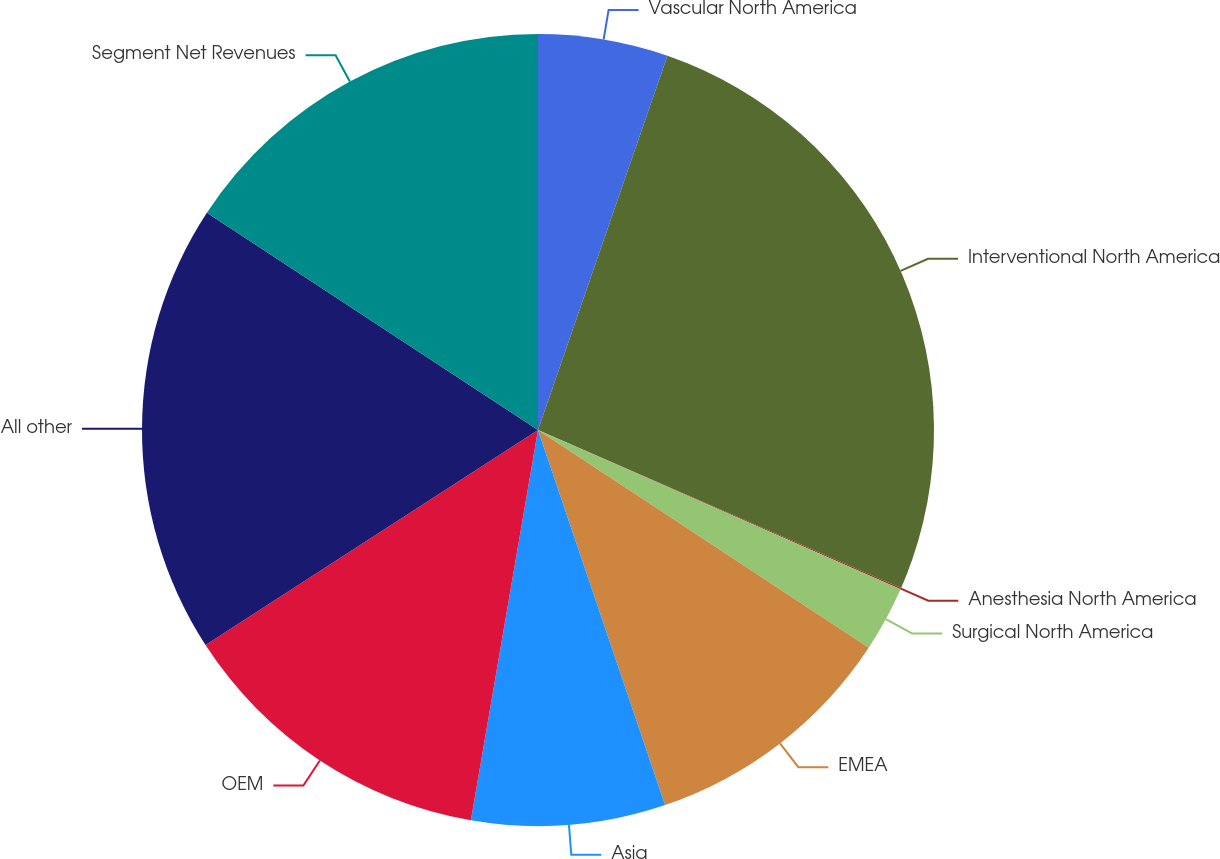<chart> <loc_0><loc_0><loc_500><loc_500><pie_chart><fcel>Vascular North America<fcel>Interventional North America<fcel>Anesthesia North America<fcel>Surgical North America<fcel>EMEA<fcel>Asia<fcel>OEM<fcel>All other<fcel>Segment Net Revenues<nl><fcel>5.3%<fcel>26.23%<fcel>0.06%<fcel>2.68%<fcel>10.53%<fcel>7.91%<fcel>13.15%<fcel>18.38%<fcel>15.76%<nl></chart> 